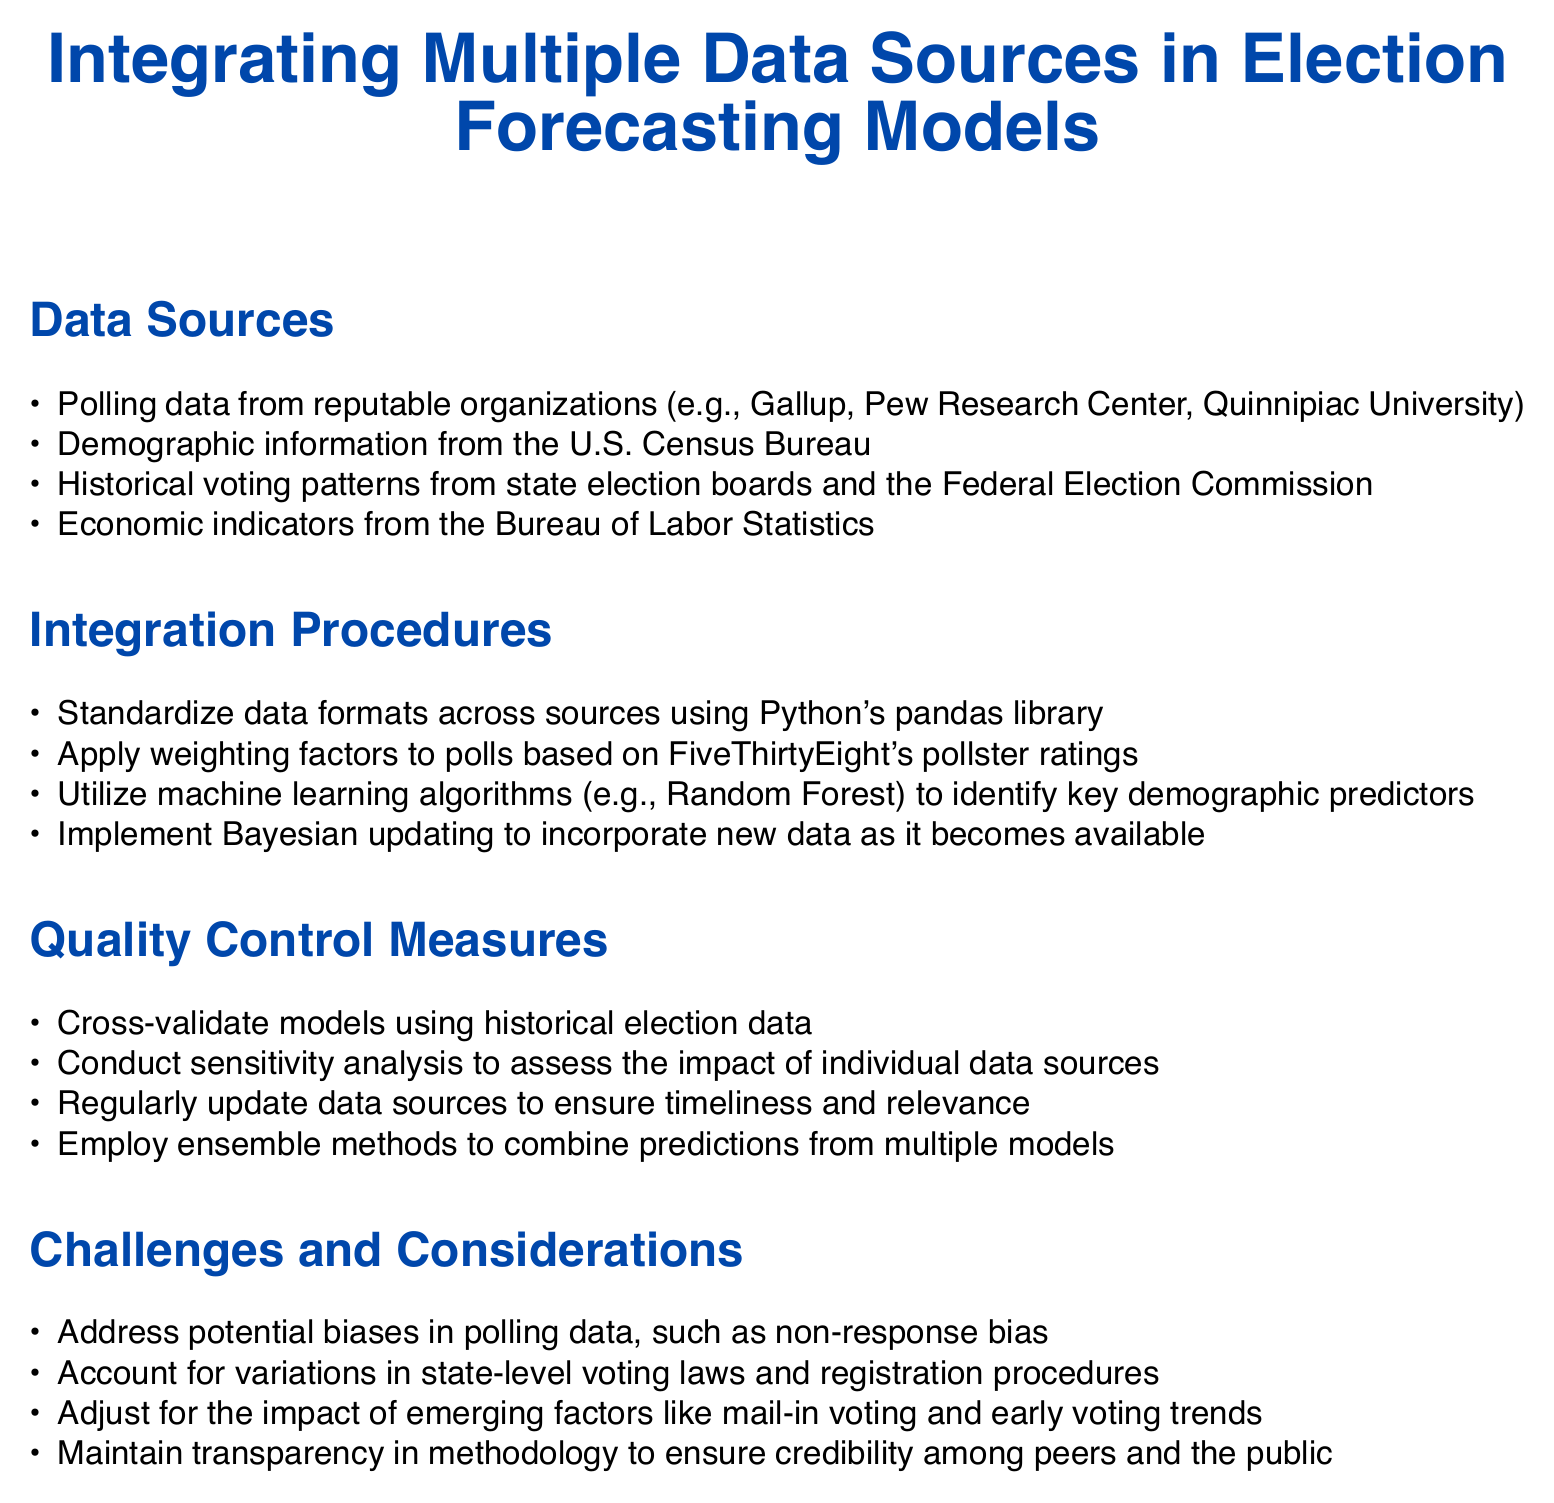What is the title of the document? The title is stated at the center of the document, highlighting the main topic of discussion.
Answer: Integrating Multiple Data Sources in Election Forecasting Models What are the polling data sources mentioned? The document lists several reputable organizations known for conducting polls in the U.S.
Answer: Gallup, Pew Research Center, Quinnipiac University Which library is used for data standardization? The document specifies a particular library in Python utilized for data preparation.
Answer: pandas What algorithm is mentioned for identifying demographic predictors? The integration procedures include a machine learning technique noted for its effectiveness in analyzing data patterns.
Answer: Random Forest What quality control measure involves updating data? The document addresses the importance of maintaining currentness in data for its accuracy and relevance.
Answer: Regularly update data sources What challenge is related to polling data? One of the considerations presented involves a common issue that could affect the accuracy of polls.
Answer: Non-response bias Which methods are used to combine predictions? The document refers to techniques that enhance prediction performance by integrating multiple models' outputs.
Answer: Ensemble methods What is the impact of emerging factors mentioned? The document highlights a notable trend affecting voting behaviors that needs consideration in forecasting.
Answer: Mail-in voting and early voting trends 